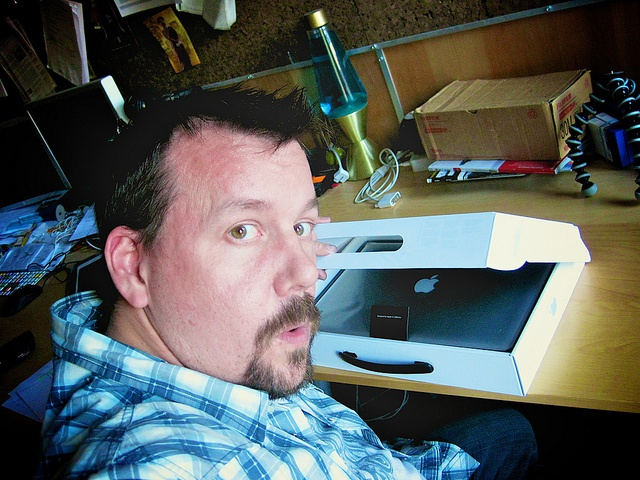Describe the objects in this image and their specific colors. I can see people in black, lightpink, lightgray, and lightblue tones and laptop in black, blue, teal, and darkblue tones in this image. 